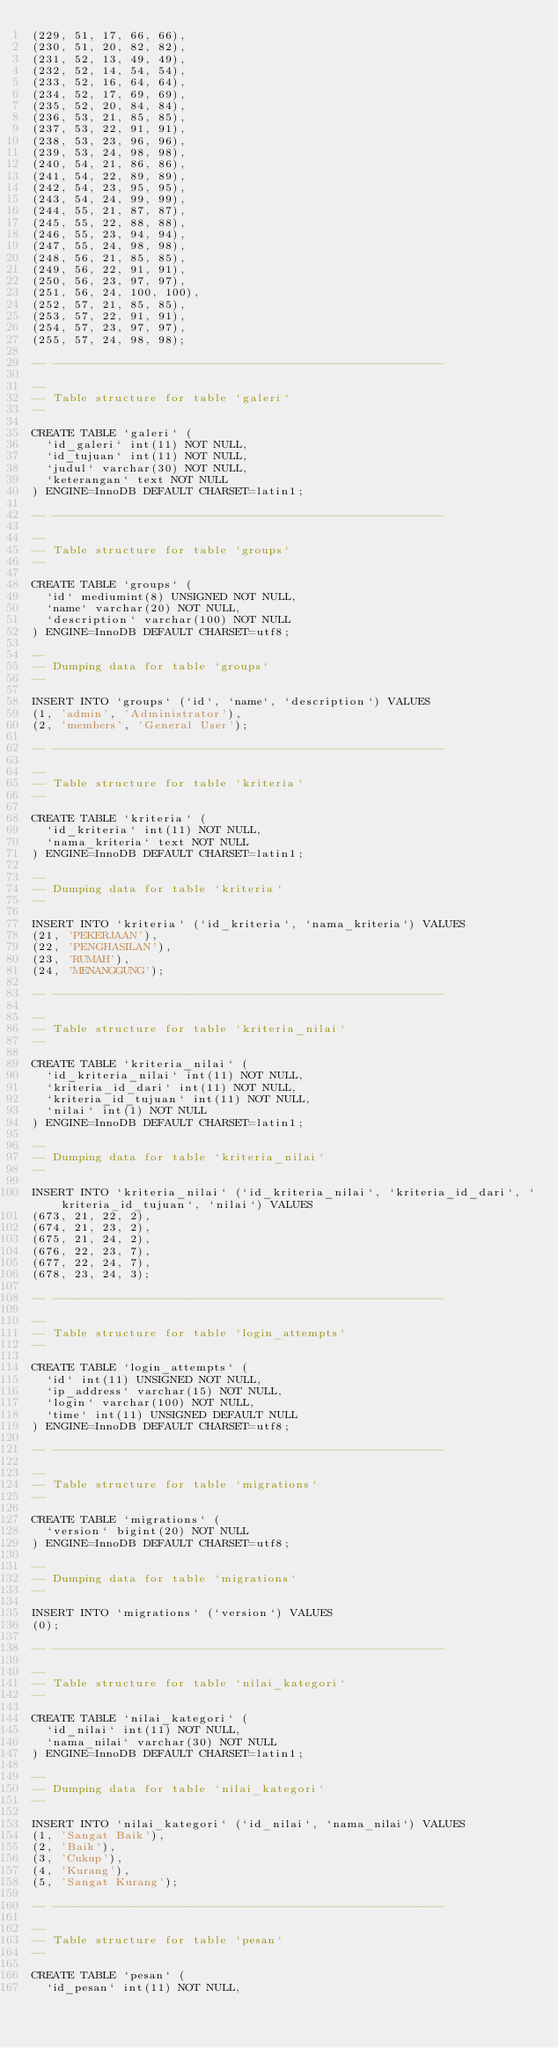<code> <loc_0><loc_0><loc_500><loc_500><_SQL_>(229, 51, 17, 66, 66),
(230, 51, 20, 82, 82),
(231, 52, 13, 49, 49),
(232, 52, 14, 54, 54),
(233, 52, 16, 64, 64),
(234, 52, 17, 69, 69),
(235, 52, 20, 84, 84),
(236, 53, 21, 85, 85),
(237, 53, 22, 91, 91),
(238, 53, 23, 96, 96),
(239, 53, 24, 98, 98),
(240, 54, 21, 86, 86),
(241, 54, 22, 89, 89),
(242, 54, 23, 95, 95),
(243, 54, 24, 99, 99),
(244, 55, 21, 87, 87),
(245, 55, 22, 88, 88),
(246, 55, 23, 94, 94),
(247, 55, 24, 98, 98),
(248, 56, 21, 85, 85),
(249, 56, 22, 91, 91),
(250, 56, 23, 97, 97),
(251, 56, 24, 100, 100),
(252, 57, 21, 85, 85),
(253, 57, 22, 91, 91),
(254, 57, 23, 97, 97),
(255, 57, 24, 98, 98);

-- --------------------------------------------------------

--
-- Table structure for table `galeri`
--

CREATE TABLE `galeri` (
  `id_galeri` int(11) NOT NULL,
  `id_tujuan` int(11) NOT NULL,
  `judul` varchar(30) NOT NULL,
  `keterangan` text NOT NULL
) ENGINE=InnoDB DEFAULT CHARSET=latin1;

-- --------------------------------------------------------

--
-- Table structure for table `groups`
--

CREATE TABLE `groups` (
  `id` mediumint(8) UNSIGNED NOT NULL,
  `name` varchar(20) NOT NULL,
  `description` varchar(100) NOT NULL
) ENGINE=InnoDB DEFAULT CHARSET=utf8;

--
-- Dumping data for table `groups`
--

INSERT INTO `groups` (`id`, `name`, `description`) VALUES
(1, 'admin', 'Administrator'),
(2, 'members', 'General User');

-- --------------------------------------------------------

--
-- Table structure for table `kriteria`
--

CREATE TABLE `kriteria` (
  `id_kriteria` int(11) NOT NULL,
  `nama_kriteria` text NOT NULL
) ENGINE=InnoDB DEFAULT CHARSET=latin1;

--
-- Dumping data for table `kriteria`
--

INSERT INTO `kriteria` (`id_kriteria`, `nama_kriteria`) VALUES
(21, 'PEKERJAAN'),
(22, 'PENGHASILAN'),
(23, 'RUMAH'),
(24, 'MENANGGUNG');

-- --------------------------------------------------------

--
-- Table structure for table `kriteria_nilai`
--

CREATE TABLE `kriteria_nilai` (
  `id_kriteria_nilai` int(11) NOT NULL,
  `kriteria_id_dari` int(11) NOT NULL,
  `kriteria_id_tujuan` int(11) NOT NULL,
  `nilai` int(1) NOT NULL
) ENGINE=InnoDB DEFAULT CHARSET=latin1;

--
-- Dumping data for table `kriteria_nilai`
--

INSERT INTO `kriteria_nilai` (`id_kriteria_nilai`, `kriteria_id_dari`, `kriteria_id_tujuan`, `nilai`) VALUES
(673, 21, 22, 2),
(674, 21, 23, 2),
(675, 21, 24, 2),
(676, 22, 23, 7),
(677, 22, 24, 7),
(678, 23, 24, 3);

-- --------------------------------------------------------

--
-- Table structure for table `login_attempts`
--

CREATE TABLE `login_attempts` (
  `id` int(11) UNSIGNED NOT NULL,
  `ip_address` varchar(15) NOT NULL,
  `login` varchar(100) NOT NULL,
  `time` int(11) UNSIGNED DEFAULT NULL
) ENGINE=InnoDB DEFAULT CHARSET=utf8;

-- --------------------------------------------------------

--
-- Table structure for table `migrations`
--

CREATE TABLE `migrations` (
  `version` bigint(20) NOT NULL
) ENGINE=InnoDB DEFAULT CHARSET=utf8;

--
-- Dumping data for table `migrations`
--

INSERT INTO `migrations` (`version`) VALUES
(0);

-- --------------------------------------------------------

--
-- Table structure for table `nilai_kategori`
--

CREATE TABLE `nilai_kategori` (
  `id_nilai` int(11) NOT NULL,
  `nama_nilai` varchar(30) NOT NULL
) ENGINE=InnoDB DEFAULT CHARSET=latin1;

--
-- Dumping data for table `nilai_kategori`
--

INSERT INTO `nilai_kategori` (`id_nilai`, `nama_nilai`) VALUES
(1, 'Sangat Baik'),
(2, 'Baik'),
(3, 'Cukup'),
(4, 'Kurang'),
(5, 'Sangat Kurang');

-- --------------------------------------------------------

--
-- Table structure for table `pesan`
--

CREATE TABLE `pesan` (
  `id_pesan` int(11) NOT NULL,</code> 